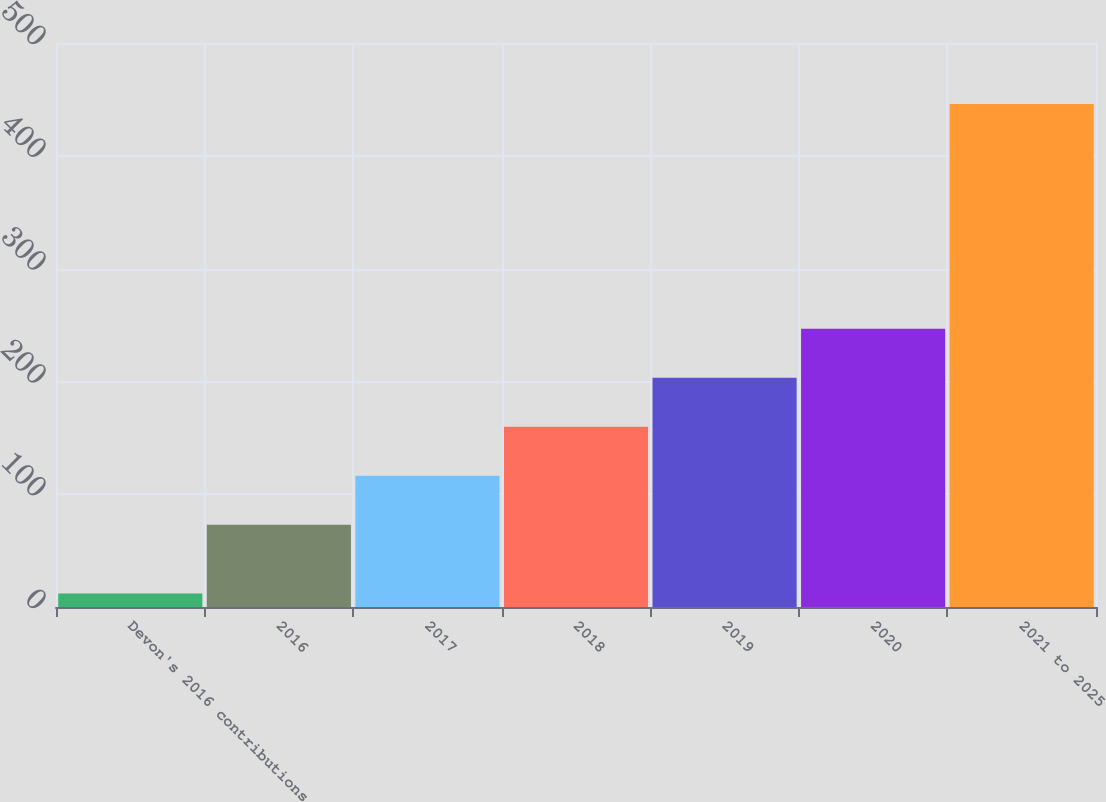Convert chart. <chart><loc_0><loc_0><loc_500><loc_500><bar_chart><fcel>Devon's 2016 contributions<fcel>2016<fcel>2017<fcel>2018<fcel>2019<fcel>2020<fcel>2021 to 2025<nl><fcel>12<fcel>73<fcel>116.4<fcel>159.8<fcel>203.2<fcel>246.6<fcel>446<nl></chart> 